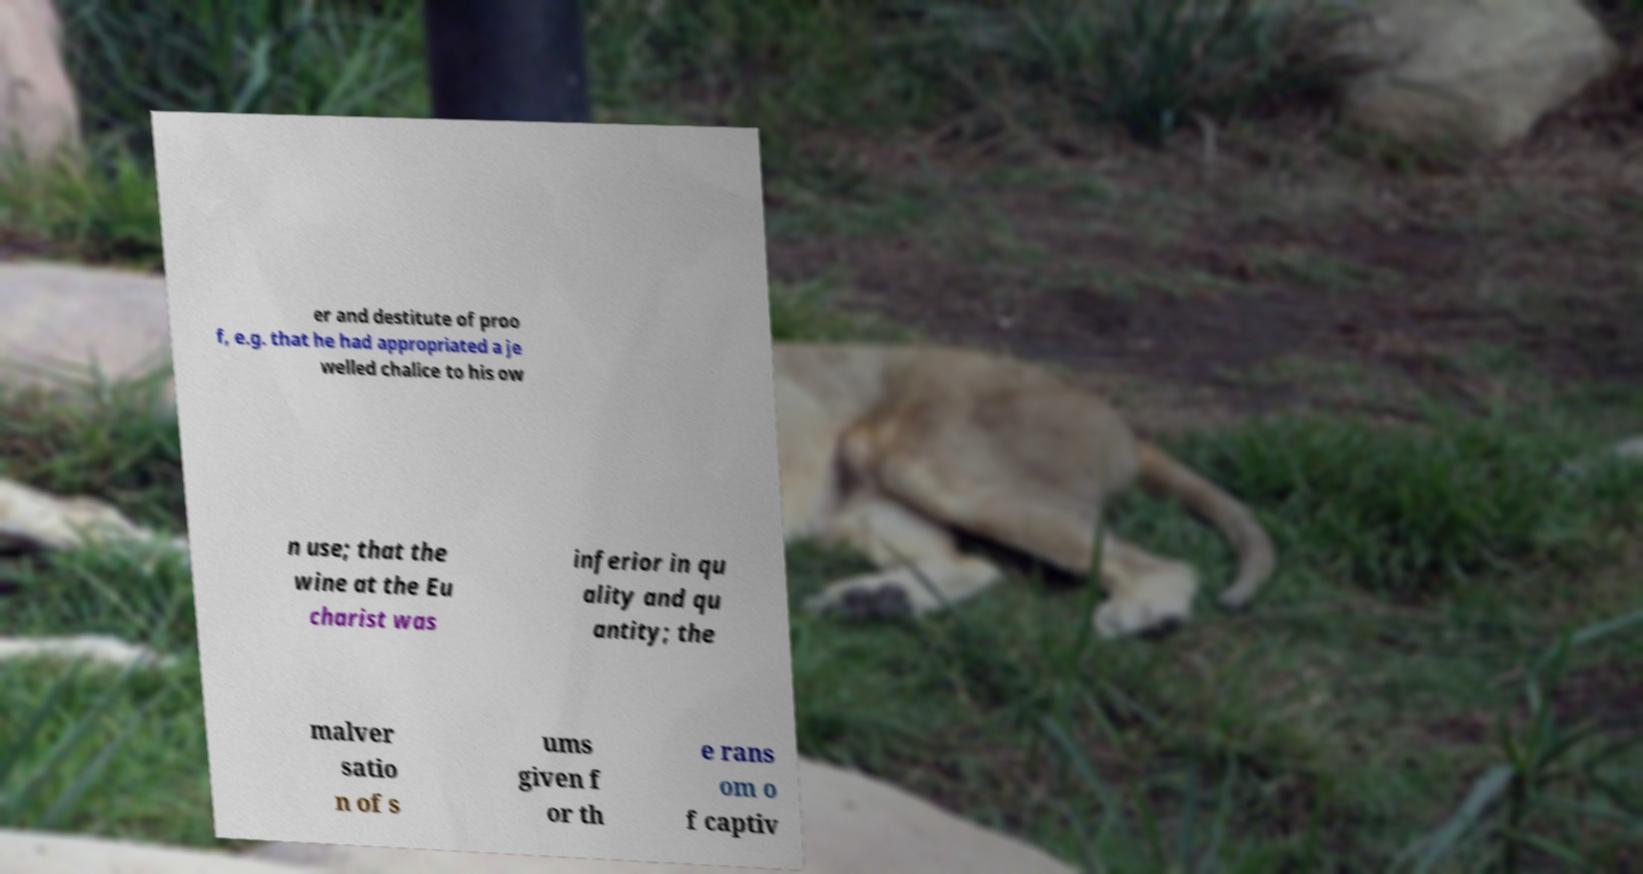For documentation purposes, I need the text within this image transcribed. Could you provide that? er and destitute of proo f, e.g. that he had appropriated a je welled chalice to his ow n use; that the wine at the Eu charist was inferior in qu ality and qu antity; the malver satio n of s ums given f or th e rans om o f captiv 